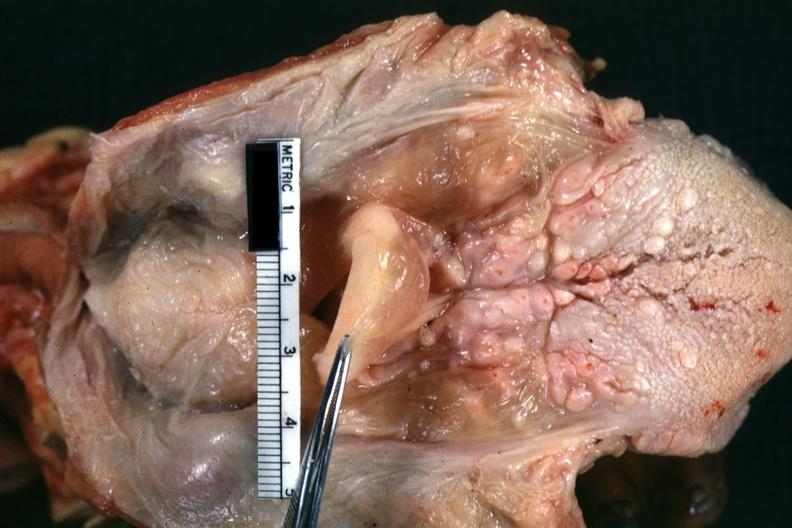what is present?
Answer the question using a single word or phrase. Larynx 